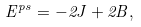Convert formula to latex. <formula><loc_0><loc_0><loc_500><loc_500>E ^ { p s } = - 2 J + 2 B ,</formula> 